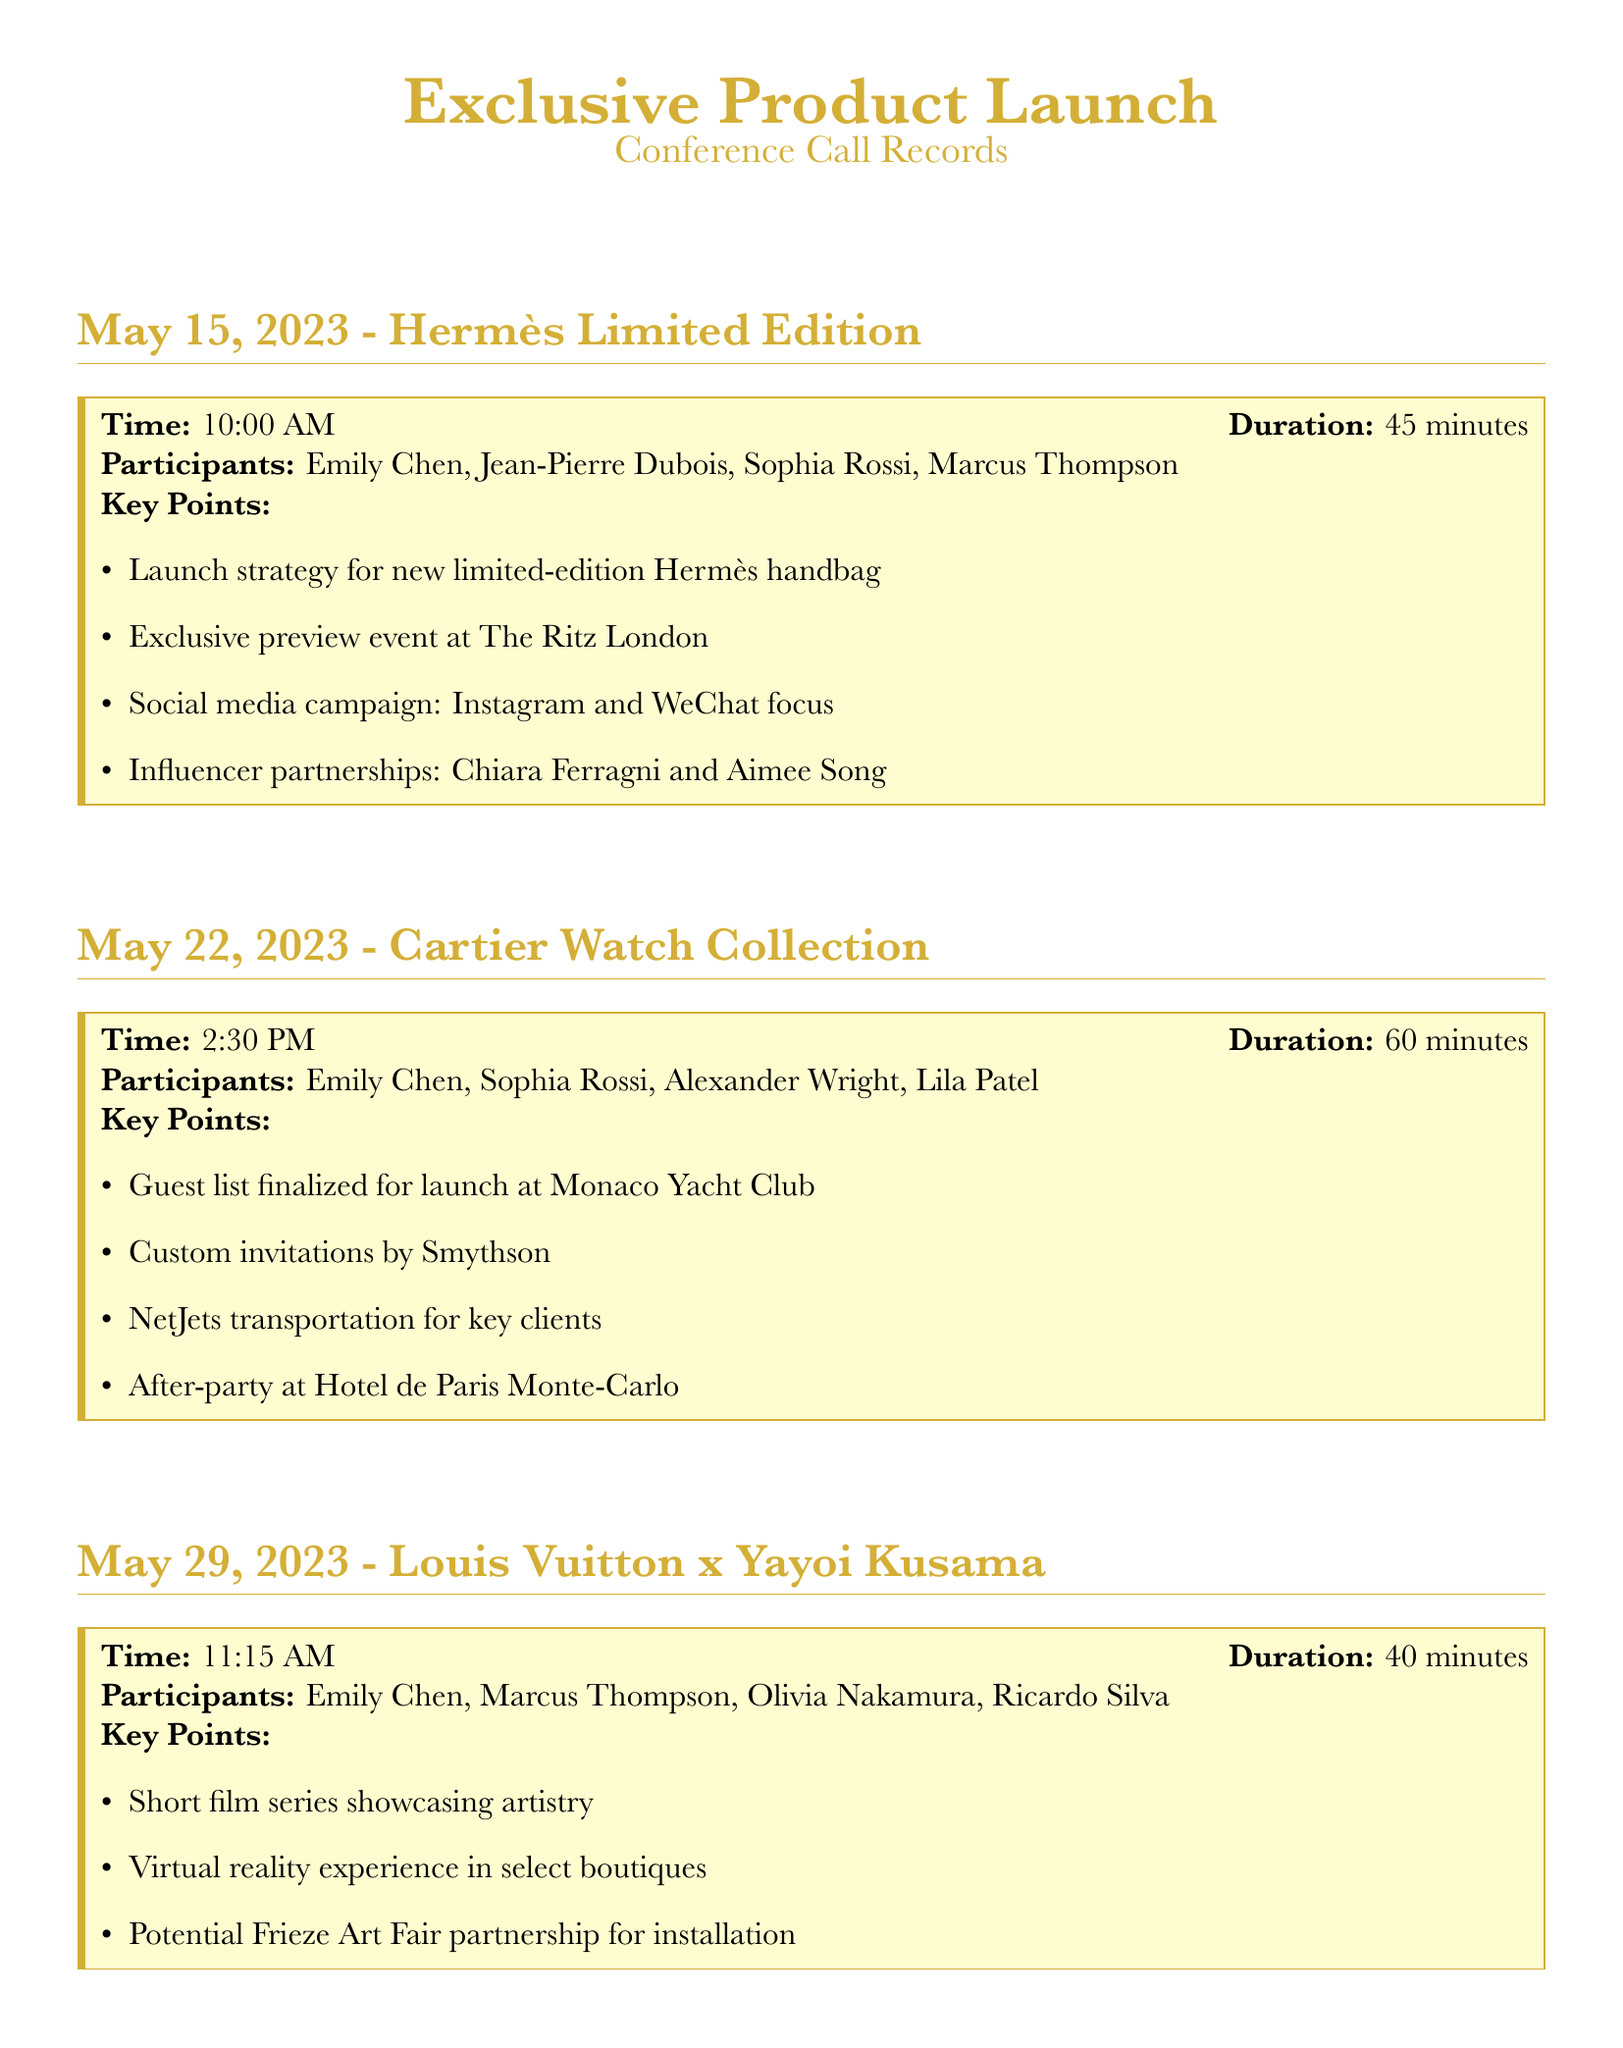What is the duration of the call on May 15, 2023? The duration is specified in the call record for May 15, which is 45 minutes.
Answer: 45 minutes Who participated in the call on May 22, 2023? The participants for the call on May 22 are listed in the document. They are Emily Chen, Sophia Rossi, Alexander Wright, and Lila Patel.
Answer: Emily Chen, Sophia Rossi, Alexander Wright, Lila Patel What is the focus of the social media campaign for the Hermès handbag? The document states that the social media campaign is focused on Instagram and WeChat.
Answer: Instagram and WeChat When is the launch for the Cartier Watch Collection scheduled? The launch for the Cartier Watch Collection is noted to take place at the Monaco Yacht Club.
Answer: Monaco Yacht Club What exclusive experience is planned for the Louis Vuitton x Yayoi Kusama launch? The document mentions a virtual reality experience planned in select boutiques.
Answer: Virtual reality experience How many minutes did the call discussing the Louis Vuitton x Yayoi Kusama last? The call lasted for 40 minutes, as indicated in the record.
Answer: 40 minutes What notable partnership was mentioned for the Louis Vuitton x Yayoi Kusama call? The potential partnership mentioned for the call was with Frieze Art Fair.
Answer: Frieze Art Fair What type of invitations will be used for the Cartier Watch Collection launch? The type of invitations specified in the document are custom invitations by Smythson.
Answer: Custom invitations by Smythson 